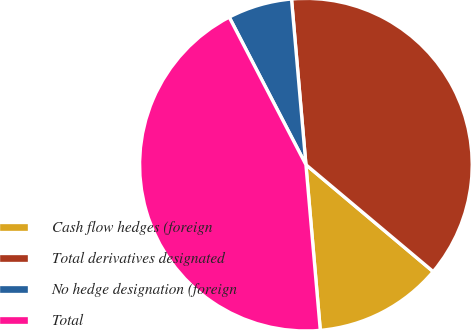<chart> <loc_0><loc_0><loc_500><loc_500><pie_chart><fcel>Cash flow hedges (foreign<fcel>Total derivatives designated<fcel>No hedge designation (foreign<fcel>Total<nl><fcel>12.5%<fcel>37.5%<fcel>6.25%<fcel>43.75%<nl></chart> 